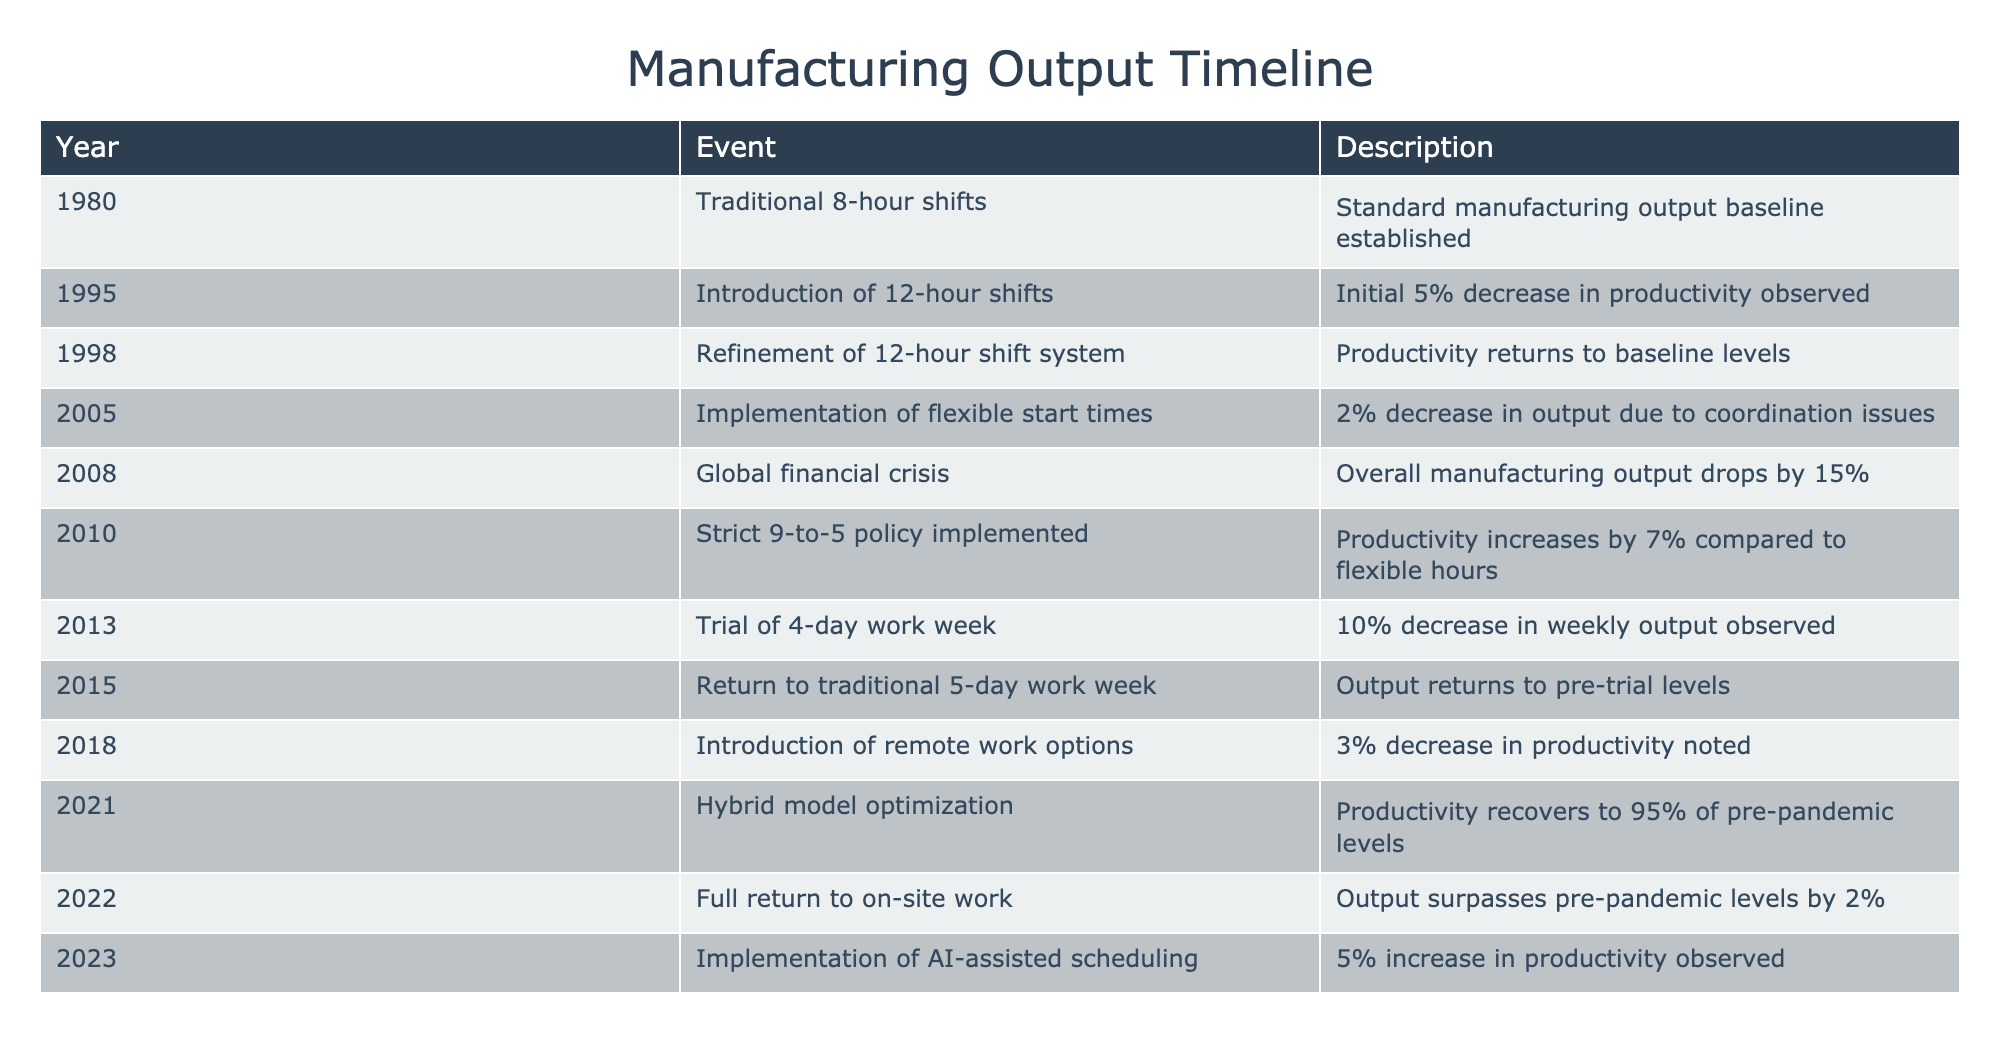What year did the implementation of flexible start times occur? According to the table, the flexible start times were implemented in 2005, as indicated in the "Year" column.
Answer: 2005 What was the percentage drop in output during the global financial crisis? The global financial crisis occurred in 2008, and according to the table, it resulted in a 15% decrease in overall manufacturing output.
Answer: 15% Was productivity higher during the strict 9-to-5 policy than under flexible hours? Yes, the strict 9-to-5 policy resulted in a 7% increase in productivity compared to the flexible hours, as evidenced by the values presented in the table.
Answer: Yes How much did productivity recover by 2021 compared to pre-pandemic levels? In 2021, productivity recovered to 95% of pre-pandemic levels. To find the difference from full recovery (100%), we subtract 95% from 100%, leading to a 5% shortfall from full pre-pandemic productivity.
Answer: 5% What was the net change in productivity from the implementation of AI-assisted scheduling in 2023 compared to the traditional 8-hour shifts established in 1980? From 1980 to 2023, AI-assisted scheduling increased productivity by 5%. However, since the baseline for 1980 is not quantified in the table, we can only state the last recorded increase of 5%. Therefore, the question cannot be answered with a single value relating to the 1980 baseline.
Answer: Indeterminate In which year was a trial of the 4-day work week conducted, and what was its impact on weekly output? The trial of the 4-day work week occurred in 2013, and it resulted in a 10% decrease in weekly output, as mentioned in the description column of that row.
Answer: 2013, 10% decrease Did the introduction of remote work options lead to an increase or a decrease in productivity? The introduction of remote work options in 2018 led to a decrease in productivity, as indicated by the 3% noted decrease in the description for that year.
Answer: Decrease What is the trend of productivity from the year 2010 to 2021 in terms of percentage change? In 2010, there was a 7% increase in productivity due to the strict 9-to-5 policy, which then saw productivity recover to 95% of pre-pandemic levels in 2021. This indicates a recovery trend, but to derive an exact percentage change, we would require the 2010 baseline; thus, a definitive percentage change cannot be resolved solely from the data available for the year 2021.
Answer: Indeterminate 